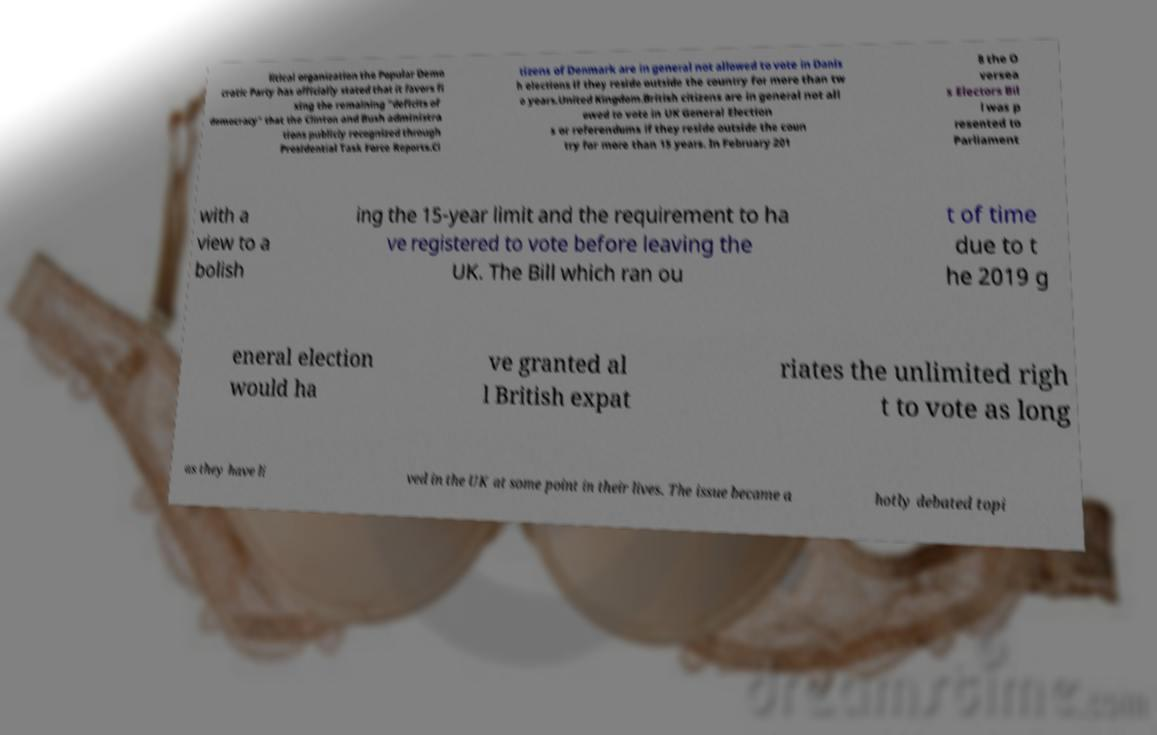Could you extract and type out the text from this image? litical organization the Popular Demo cratic Party has officially stated that it favors fi xing the remaining "deficits of democracy" that the Clinton and Bush administra tions publicly recognized through Presidential Task Force Reports.Ci tizens of Denmark are in general not allowed to vote in Danis h elections if they reside outside the country for more than tw o years.United Kingdom.British citizens are in general not all owed to vote in UK General Election s or referendums if they reside outside the coun try for more than 15 years. In February 201 8 the O versea s Electors Bil l was p resented to Parliament with a view to a bolish ing the 15-year limit and the requirement to ha ve registered to vote before leaving the UK. The Bill which ran ou t of time due to t he 2019 g eneral election would ha ve granted al l British expat riates the unlimited righ t to vote as long as they have li ved in the UK at some point in their lives. The issue became a hotly debated topi 